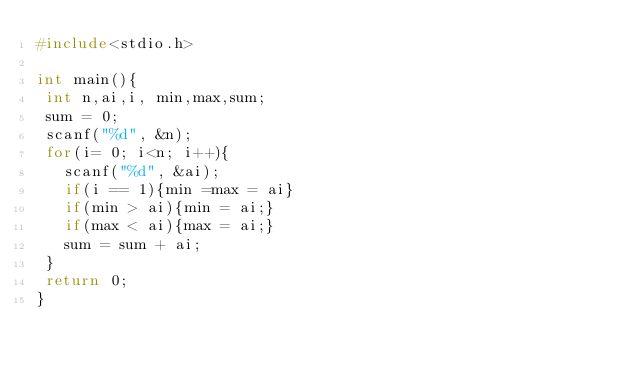<code> <loc_0><loc_0><loc_500><loc_500><_C_>#include<stdio.h>

int main(){
 int n,ai,i, min,max,sum;
 sum = 0;
 scanf("%d", &n);
 for(i= 0; i<n; i++){
   scanf("%d", &ai);
   if(i == 1){min =max = ai}
   if(min > ai){min = ai;}
   if(max < ai){max = ai;}
   sum = sum + ai;
 }
 return 0;
}
  
  </code> 